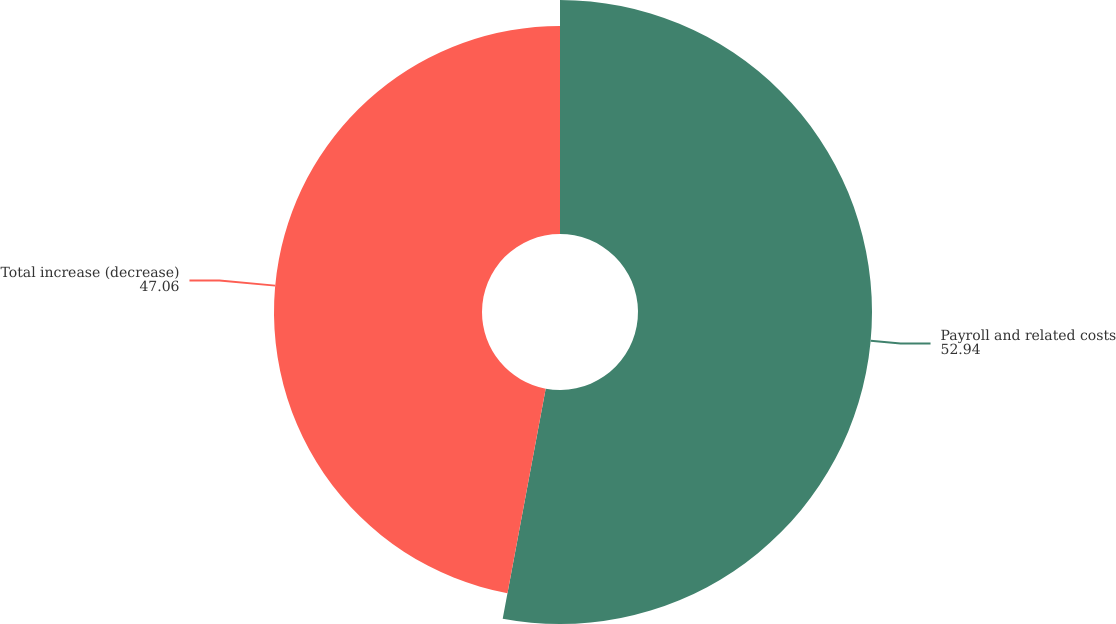Convert chart to OTSL. <chart><loc_0><loc_0><loc_500><loc_500><pie_chart><fcel>Payroll and related costs<fcel>Total increase (decrease)<nl><fcel>52.94%<fcel>47.06%<nl></chart> 